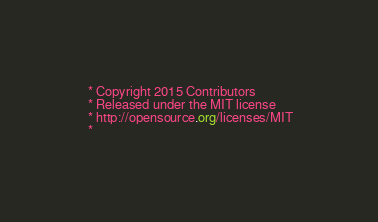<code> <loc_0><loc_0><loc_500><loc_500><_CSS_> * Copyright 2015 Contributors
 * Released under the MIT license
 * http://opensource.org/licenses/MIT
 *</code> 